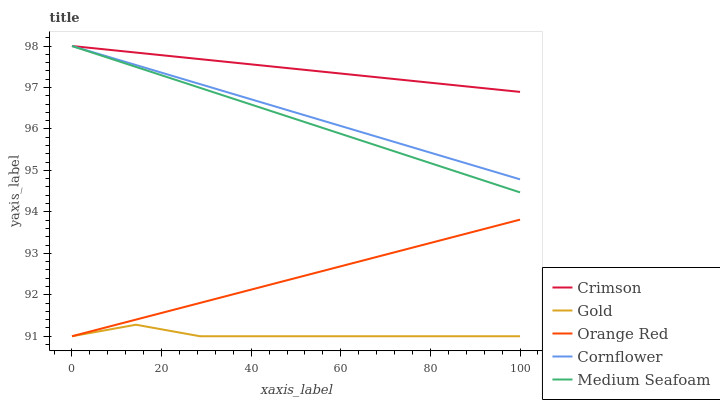Does Cornflower have the minimum area under the curve?
Answer yes or no. No. Does Cornflower have the maximum area under the curve?
Answer yes or no. No. Is Cornflower the smoothest?
Answer yes or no. No. Is Cornflower the roughest?
Answer yes or no. No. Does Cornflower have the lowest value?
Answer yes or no. No. Does Orange Red have the highest value?
Answer yes or no. No. Is Orange Red less than Crimson?
Answer yes or no. Yes. Is Crimson greater than Orange Red?
Answer yes or no. Yes. Does Orange Red intersect Crimson?
Answer yes or no. No. 